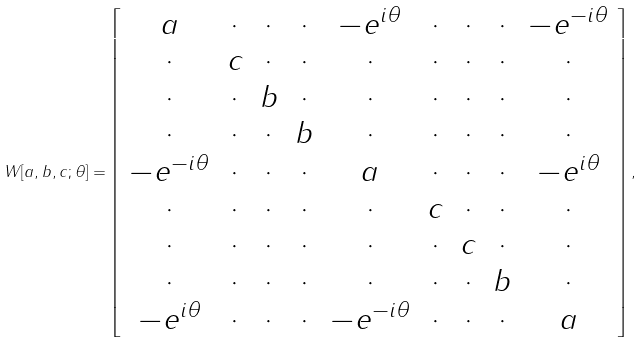Convert formula to latex. <formula><loc_0><loc_0><loc_500><loc_500>W [ a , b , c ; \theta ] = \left [ \begin{array} { c c c c c c c c c c c } a & \cdot & \cdot & \cdot & - e ^ { i \theta } & \cdot & \cdot & \cdot & - e ^ { - i \theta } \\ \cdot & c & \cdot & \cdot & \cdot & \cdot & \cdot & \cdot & \cdot \\ \cdot & \cdot & b & \cdot & \cdot & \cdot & \cdot & \cdot & \cdot \\ \cdot & \cdot & \cdot & b & \cdot & \cdot & \cdot & \cdot & \cdot \\ - e ^ { - i \theta } & \cdot & \cdot & \cdot & a & \cdot & \cdot & \cdot & - e ^ { i \theta } \\ \cdot & \cdot & \cdot & \cdot & \cdot & c & \cdot & \cdot & \cdot \\ \cdot & \cdot & \cdot & \cdot & \cdot & \cdot & c & \cdot & \cdot \\ \cdot & \cdot & \cdot & \cdot & \cdot & \cdot & \cdot & b & \cdot \\ - e ^ { i \theta } & \cdot & \cdot & \cdot & - e ^ { - i \theta } & \cdot & \cdot & \cdot & a \end{array} \right ] ,</formula> 